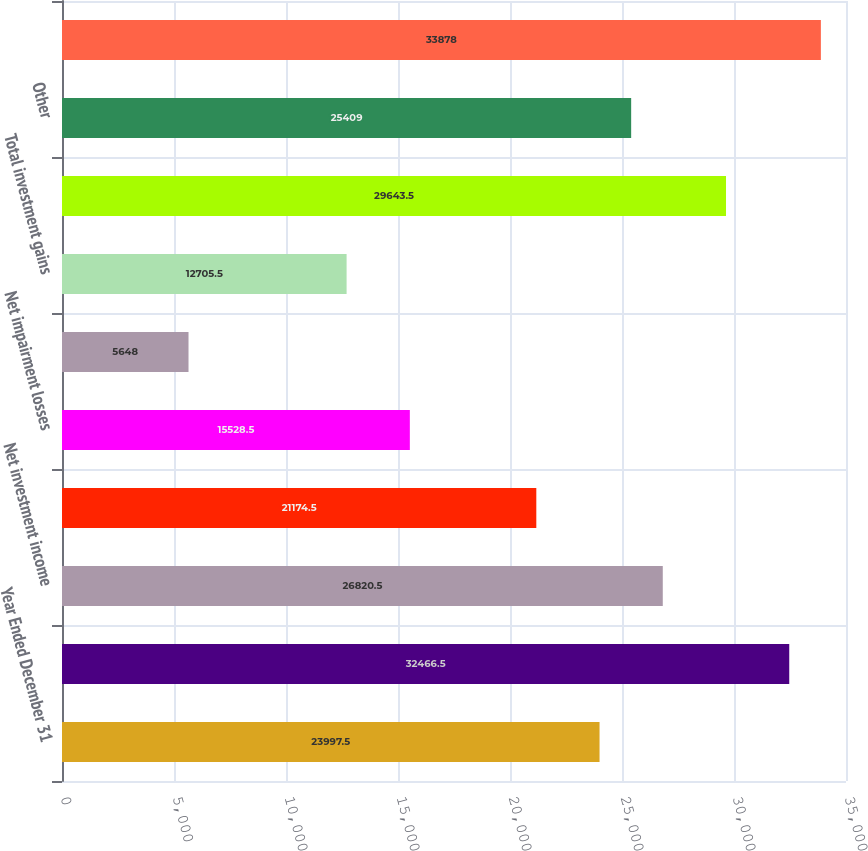Convert chart. <chart><loc_0><loc_0><loc_500><loc_500><bar_chart><fcel>Year Ended December 31<fcel>Insurance premiums<fcel>Net investment income<fcel>Other-than-temporary<fcel>Net impairment losses<fcel>Other net investment gains<fcel>Total investment gains<fcel>Contract drilling revenues<fcel>Other<fcel>Total<nl><fcel>23997.5<fcel>32466.5<fcel>26820.5<fcel>21174.5<fcel>15528.5<fcel>5648<fcel>12705.5<fcel>29643.5<fcel>25409<fcel>33878<nl></chart> 